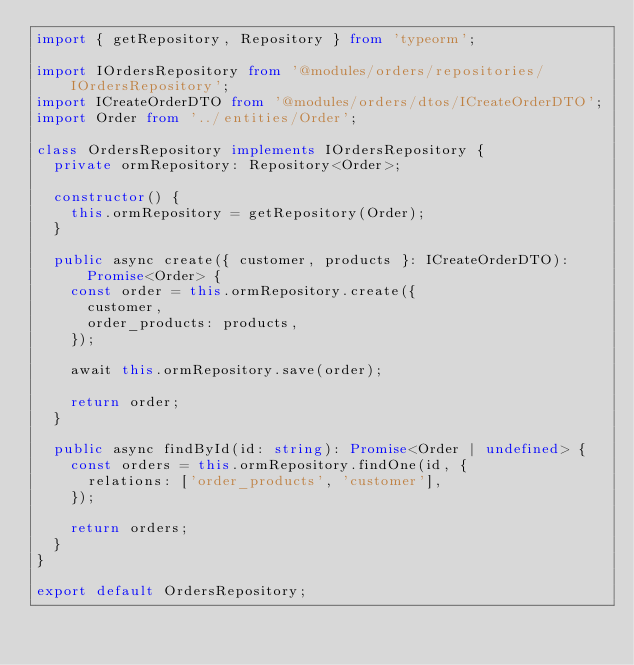Convert code to text. <code><loc_0><loc_0><loc_500><loc_500><_TypeScript_>import { getRepository, Repository } from 'typeorm';

import IOrdersRepository from '@modules/orders/repositories/IOrdersRepository';
import ICreateOrderDTO from '@modules/orders/dtos/ICreateOrderDTO';
import Order from '../entities/Order';

class OrdersRepository implements IOrdersRepository {
  private ormRepository: Repository<Order>;

  constructor() {
    this.ormRepository = getRepository(Order);
  }

  public async create({ customer, products }: ICreateOrderDTO): Promise<Order> {
    const order = this.ormRepository.create({
      customer,
      order_products: products,
    });

    await this.ormRepository.save(order);

    return order;
  }

  public async findById(id: string): Promise<Order | undefined> {
    const orders = this.ormRepository.findOne(id, {
      relations: ['order_products', 'customer'],
    });

    return orders;
  }
}

export default OrdersRepository;
</code> 